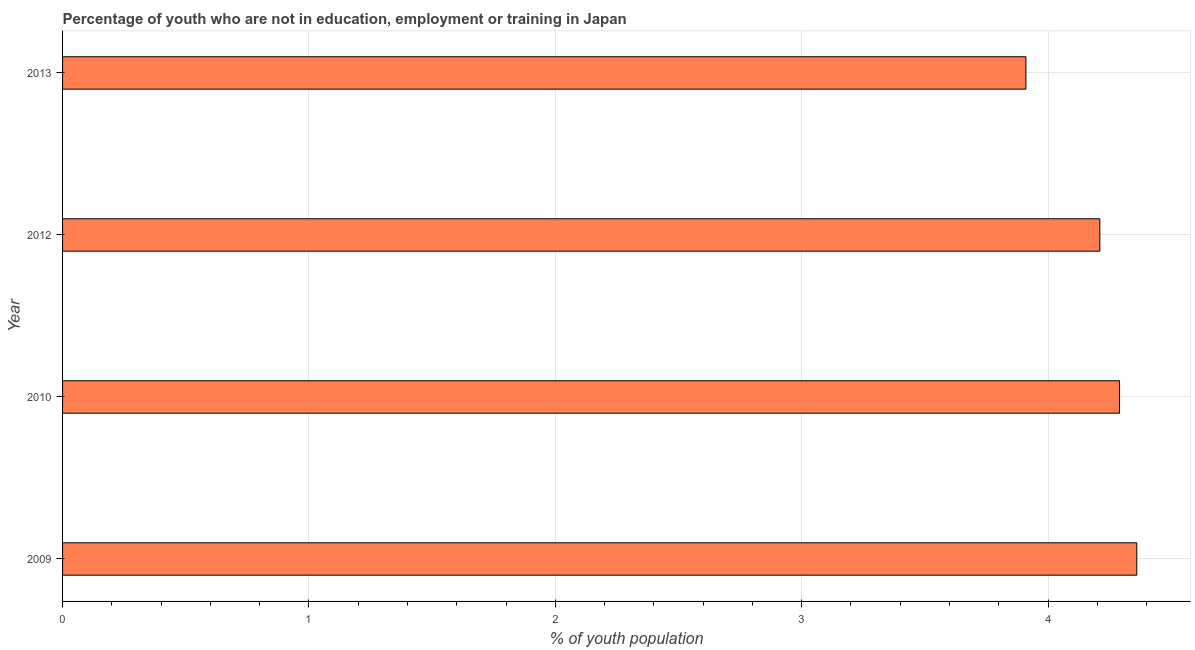Does the graph contain any zero values?
Offer a very short reply. No. Does the graph contain grids?
Keep it short and to the point. Yes. What is the title of the graph?
Keep it short and to the point. Percentage of youth who are not in education, employment or training in Japan. What is the label or title of the X-axis?
Make the answer very short. % of youth population. What is the label or title of the Y-axis?
Offer a terse response. Year. What is the unemployed youth population in 2012?
Offer a very short reply. 4.21. Across all years, what is the maximum unemployed youth population?
Your answer should be very brief. 4.36. Across all years, what is the minimum unemployed youth population?
Your response must be concise. 3.91. In which year was the unemployed youth population maximum?
Make the answer very short. 2009. What is the sum of the unemployed youth population?
Keep it short and to the point. 16.77. What is the difference between the unemployed youth population in 2012 and 2013?
Your answer should be compact. 0.3. What is the average unemployed youth population per year?
Your answer should be very brief. 4.19. What is the median unemployed youth population?
Provide a succinct answer. 4.25. In how many years, is the unemployed youth population greater than 3.2 %?
Provide a succinct answer. 4. Do a majority of the years between 2009 and 2012 (inclusive) have unemployed youth population greater than 2.2 %?
Keep it short and to the point. Yes. What is the ratio of the unemployed youth population in 2009 to that in 2010?
Offer a terse response. 1.02. What is the difference between the highest and the second highest unemployed youth population?
Offer a terse response. 0.07. What is the difference between the highest and the lowest unemployed youth population?
Ensure brevity in your answer.  0.45. In how many years, is the unemployed youth population greater than the average unemployed youth population taken over all years?
Your answer should be compact. 3. What is the % of youth population in 2009?
Offer a terse response. 4.36. What is the % of youth population in 2010?
Offer a very short reply. 4.29. What is the % of youth population in 2012?
Provide a succinct answer. 4.21. What is the % of youth population of 2013?
Keep it short and to the point. 3.91. What is the difference between the % of youth population in 2009 and 2010?
Provide a succinct answer. 0.07. What is the difference between the % of youth population in 2009 and 2013?
Give a very brief answer. 0.45. What is the difference between the % of youth population in 2010 and 2012?
Make the answer very short. 0.08. What is the difference between the % of youth population in 2010 and 2013?
Ensure brevity in your answer.  0.38. What is the ratio of the % of youth population in 2009 to that in 2012?
Your answer should be compact. 1.04. What is the ratio of the % of youth population in 2009 to that in 2013?
Your response must be concise. 1.11. What is the ratio of the % of youth population in 2010 to that in 2012?
Offer a very short reply. 1.02. What is the ratio of the % of youth population in 2010 to that in 2013?
Provide a short and direct response. 1.1. What is the ratio of the % of youth population in 2012 to that in 2013?
Offer a terse response. 1.08. 